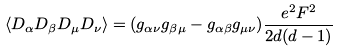Convert formula to latex. <formula><loc_0><loc_0><loc_500><loc_500>\langle D _ { \alpha } D _ { \beta } D _ { \mu } D _ { \nu } \rangle = ( g _ { \alpha \nu } g _ { \beta \mu } - g _ { \alpha \beta } g _ { \mu \nu } ) \frac { e ^ { 2 } F ^ { 2 } } { 2 d ( d - 1 ) }</formula> 